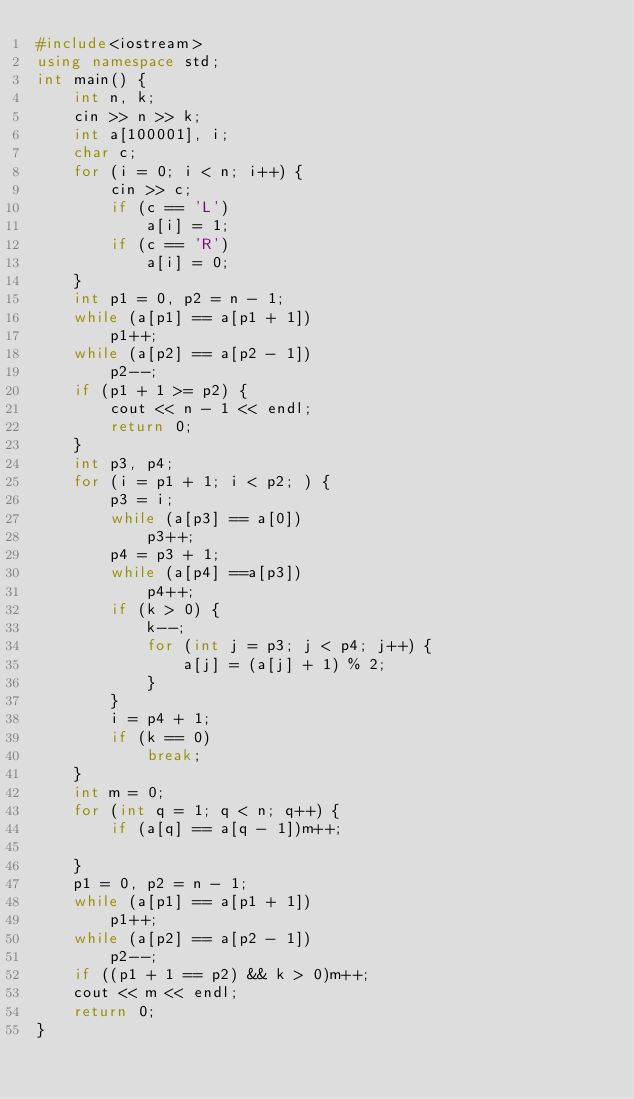<code> <loc_0><loc_0><loc_500><loc_500><_C++_>#include<iostream>
using namespace std;
int main() {
	int n, k;
	cin >> n >> k;
	int a[100001], i;
	char c;
	for (i = 0; i < n; i++) {
		cin >> c;
		if (c == 'L')
			a[i] = 1;
		if (c == 'R')
			a[i] = 0;
	}
	int p1 = 0, p2 = n - 1;
	while (a[p1] == a[p1 + 1]) 
		p1++;
	while (a[p2] == a[p2 - 1]) 
		p2--;
	if (p1 + 1 >= p2) {
		cout << n - 1 << endl;
		return 0;
	}
	int p3, p4;
	for (i = p1 + 1; i < p2; ) {
		p3 = i;
		while (a[p3] == a[0])
			p3++;
		p4 = p3 + 1;
		while (a[p4] ==a[p3])
			p4++;
		if (k > 0) {
			k--;
			for (int j = p3; j < p4; j++) {
				a[j] = (a[j] + 1) % 2;
			}
		}
		i = p4 + 1;
		if (k == 0)
			break;
	}
	int m = 0;
	for (int q = 1; q < n; q++) {
		if (a[q] == a[q - 1])m++;
		
	}
	p1 = 0, p2 = n - 1;
	while (a[p1] == a[p1 + 1])
		p1++;
	while (a[p2] == a[p2 - 1])
		p2--;
	if ((p1 + 1 == p2) && k > 0)m++;
	cout << m << endl;
	return 0;
}</code> 